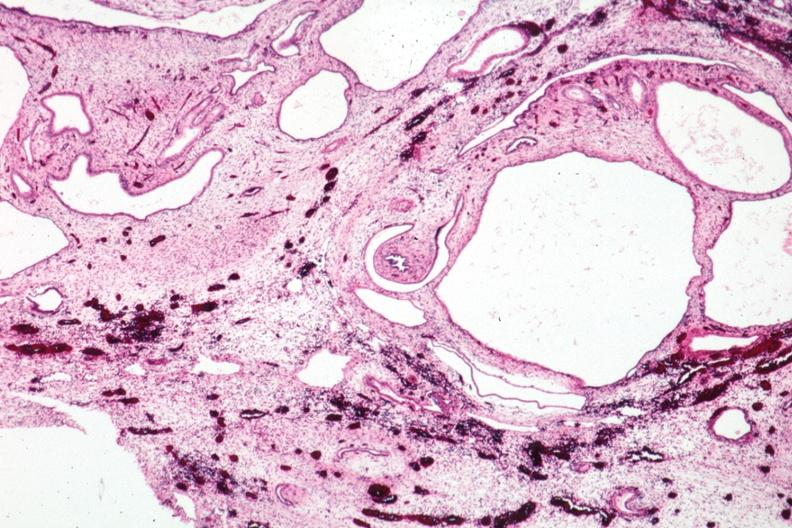s kidney present?
Answer the question using a single word or phrase. Yes 